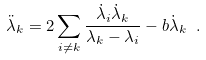<formula> <loc_0><loc_0><loc_500><loc_500>\ddot { \lambda } _ { k } = 2 \sum _ { i \neq k } \frac { \dot { \lambda } _ { i } \dot { \lambda } _ { k } } { \lambda _ { k } - \lambda _ { i } } - b \dot { \lambda } _ { k } \ .</formula> 